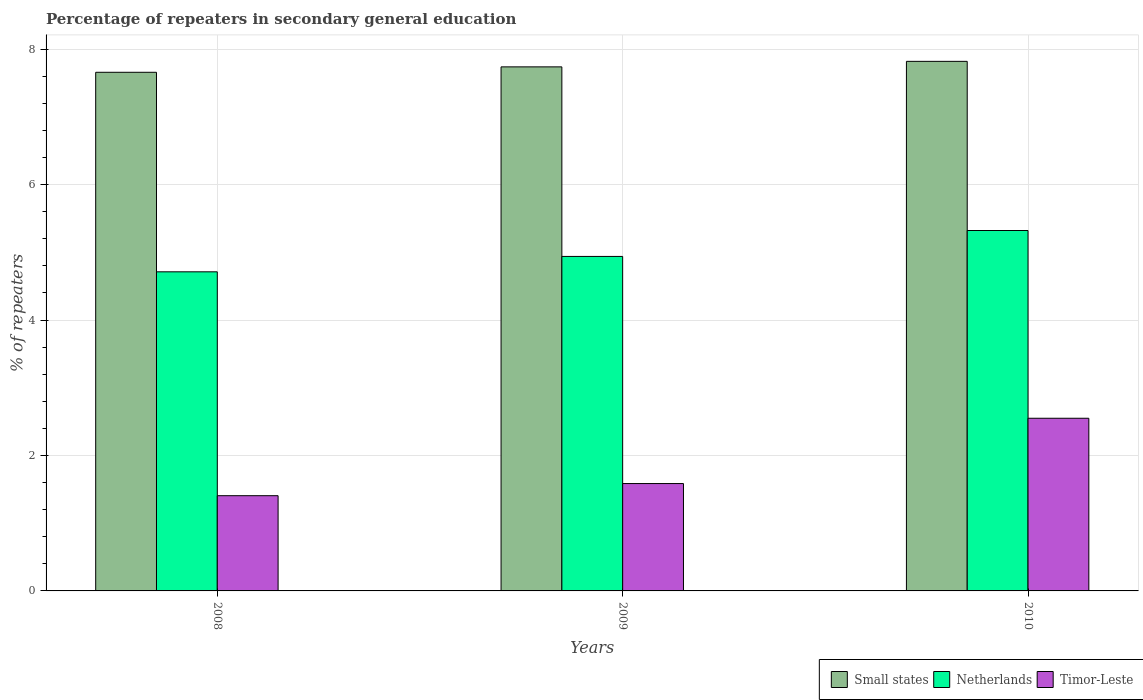How many bars are there on the 1st tick from the left?
Ensure brevity in your answer.  3. How many bars are there on the 1st tick from the right?
Your response must be concise. 3. In how many cases, is the number of bars for a given year not equal to the number of legend labels?
Your response must be concise. 0. What is the percentage of repeaters in secondary general education in Small states in 2008?
Offer a very short reply. 7.66. Across all years, what is the maximum percentage of repeaters in secondary general education in Timor-Leste?
Offer a very short reply. 2.55. Across all years, what is the minimum percentage of repeaters in secondary general education in Timor-Leste?
Offer a terse response. 1.41. In which year was the percentage of repeaters in secondary general education in Small states maximum?
Your answer should be very brief. 2010. In which year was the percentage of repeaters in secondary general education in Small states minimum?
Ensure brevity in your answer.  2008. What is the total percentage of repeaters in secondary general education in Netherlands in the graph?
Offer a terse response. 14.97. What is the difference between the percentage of repeaters in secondary general education in Small states in 2008 and that in 2010?
Your answer should be compact. -0.16. What is the difference between the percentage of repeaters in secondary general education in Small states in 2008 and the percentage of repeaters in secondary general education in Timor-Leste in 2009?
Keep it short and to the point. 6.07. What is the average percentage of repeaters in secondary general education in Small states per year?
Your answer should be very brief. 7.74. In the year 2010, what is the difference between the percentage of repeaters in secondary general education in Small states and percentage of repeaters in secondary general education in Timor-Leste?
Make the answer very short. 5.27. What is the ratio of the percentage of repeaters in secondary general education in Netherlands in 2009 to that in 2010?
Provide a short and direct response. 0.93. What is the difference between the highest and the second highest percentage of repeaters in secondary general education in Timor-Leste?
Provide a succinct answer. 0.96. What is the difference between the highest and the lowest percentage of repeaters in secondary general education in Netherlands?
Offer a very short reply. 0.61. How many bars are there?
Your response must be concise. 9. How many years are there in the graph?
Offer a terse response. 3. Are the values on the major ticks of Y-axis written in scientific E-notation?
Offer a terse response. No. Does the graph contain grids?
Give a very brief answer. Yes. How many legend labels are there?
Make the answer very short. 3. What is the title of the graph?
Your answer should be very brief. Percentage of repeaters in secondary general education. What is the label or title of the X-axis?
Keep it short and to the point. Years. What is the label or title of the Y-axis?
Offer a very short reply. % of repeaters. What is the % of repeaters of Small states in 2008?
Provide a succinct answer. 7.66. What is the % of repeaters of Netherlands in 2008?
Ensure brevity in your answer.  4.71. What is the % of repeaters of Timor-Leste in 2008?
Keep it short and to the point. 1.41. What is the % of repeaters in Small states in 2009?
Provide a short and direct response. 7.74. What is the % of repeaters in Netherlands in 2009?
Provide a succinct answer. 4.94. What is the % of repeaters of Timor-Leste in 2009?
Give a very brief answer. 1.59. What is the % of repeaters of Small states in 2010?
Ensure brevity in your answer.  7.82. What is the % of repeaters of Netherlands in 2010?
Provide a succinct answer. 5.32. What is the % of repeaters in Timor-Leste in 2010?
Keep it short and to the point. 2.55. Across all years, what is the maximum % of repeaters in Small states?
Provide a short and direct response. 7.82. Across all years, what is the maximum % of repeaters in Netherlands?
Provide a short and direct response. 5.32. Across all years, what is the maximum % of repeaters of Timor-Leste?
Your answer should be compact. 2.55. Across all years, what is the minimum % of repeaters in Small states?
Your answer should be compact. 7.66. Across all years, what is the minimum % of repeaters of Netherlands?
Provide a succinct answer. 4.71. Across all years, what is the minimum % of repeaters of Timor-Leste?
Give a very brief answer. 1.41. What is the total % of repeaters of Small states in the graph?
Offer a very short reply. 23.22. What is the total % of repeaters of Netherlands in the graph?
Your answer should be very brief. 14.97. What is the total % of repeaters in Timor-Leste in the graph?
Provide a succinct answer. 5.54. What is the difference between the % of repeaters of Small states in 2008 and that in 2009?
Give a very brief answer. -0.08. What is the difference between the % of repeaters of Netherlands in 2008 and that in 2009?
Offer a terse response. -0.23. What is the difference between the % of repeaters of Timor-Leste in 2008 and that in 2009?
Give a very brief answer. -0.18. What is the difference between the % of repeaters in Small states in 2008 and that in 2010?
Keep it short and to the point. -0.16. What is the difference between the % of repeaters in Netherlands in 2008 and that in 2010?
Make the answer very short. -0.61. What is the difference between the % of repeaters of Timor-Leste in 2008 and that in 2010?
Give a very brief answer. -1.14. What is the difference between the % of repeaters in Small states in 2009 and that in 2010?
Ensure brevity in your answer.  -0.08. What is the difference between the % of repeaters of Netherlands in 2009 and that in 2010?
Ensure brevity in your answer.  -0.38. What is the difference between the % of repeaters in Timor-Leste in 2009 and that in 2010?
Ensure brevity in your answer.  -0.96. What is the difference between the % of repeaters of Small states in 2008 and the % of repeaters of Netherlands in 2009?
Offer a terse response. 2.72. What is the difference between the % of repeaters in Small states in 2008 and the % of repeaters in Timor-Leste in 2009?
Give a very brief answer. 6.07. What is the difference between the % of repeaters of Netherlands in 2008 and the % of repeaters of Timor-Leste in 2009?
Give a very brief answer. 3.13. What is the difference between the % of repeaters in Small states in 2008 and the % of repeaters in Netherlands in 2010?
Your answer should be very brief. 2.34. What is the difference between the % of repeaters in Small states in 2008 and the % of repeaters in Timor-Leste in 2010?
Your answer should be very brief. 5.11. What is the difference between the % of repeaters of Netherlands in 2008 and the % of repeaters of Timor-Leste in 2010?
Make the answer very short. 2.16. What is the difference between the % of repeaters of Small states in 2009 and the % of repeaters of Netherlands in 2010?
Your answer should be very brief. 2.42. What is the difference between the % of repeaters of Small states in 2009 and the % of repeaters of Timor-Leste in 2010?
Provide a short and direct response. 5.19. What is the difference between the % of repeaters of Netherlands in 2009 and the % of repeaters of Timor-Leste in 2010?
Offer a terse response. 2.39. What is the average % of repeaters in Small states per year?
Offer a terse response. 7.74. What is the average % of repeaters in Netherlands per year?
Provide a short and direct response. 4.99. What is the average % of repeaters in Timor-Leste per year?
Offer a very short reply. 1.85. In the year 2008, what is the difference between the % of repeaters in Small states and % of repeaters in Netherlands?
Provide a short and direct response. 2.95. In the year 2008, what is the difference between the % of repeaters of Small states and % of repeaters of Timor-Leste?
Your answer should be very brief. 6.25. In the year 2008, what is the difference between the % of repeaters in Netherlands and % of repeaters in Timor-Leste?
Your answer should be compact. 3.31. In the year 2009, what is the difference between the % of repeaters of Small states and % of repeaters of Netherlands?
Your response must be concise. 2.8. In the year 2009, what is the difference between the % of repeaters of Small states and % of repeaters of Timor-Leste?
Offer a terse response. 6.15. In the year 2009, what is the difference between the % of repeaters of Netherlands and % of repeaters of Timor-Leste?
Your response must be concise. 3.35. In the year 2010, what is the difference between the % of repeaters in Small states and % of repeaters in Netherlands?
Provide a short and direct response. 2.5. In the year 2010, what is the difference between the % of repeaters in Small states and % of repeaters in Timor-Leste?
Ensure brevity in your answer.  5.27. In the year 2010, what is the difference between the % of repeaters of Netherlands and % of repeaters of Timor-Leste?
Offer a very short reply. 2.77. What is the ratio of the % of repeaters in Small states in 2008 to that in 2009?
Give a very brief answer. 0.99. What is the ratio of the % of repeaters of Netherlands in 2008 to that in 2009?
Make the answer very short. 0.95. What is the ratio of the % of repeaters of Timor-Leste in 2008 to that in 2009?
Provide a succinct answer. 0.89. What is the ratio of the % of repeaters in Small states in 2008 to that in 2010?
Your answer should be compact. 0.98. What is the ratio of the % of repeaters of Netherlands in 2008 to that in 2010?
Provide a succinct answer. 0.89. What is the ratio of the % of repeaters of Timor-Leste in 2008 to that in 2010?
Offer a terse response. 0.55. What is the ratio of the % of repeaters of Small states in 2009 to that in 2010?
Ensure brevity in your answer.  0.99. What is the ratio of the % of repeaters of Netherlands in 2009 to that in 2010?
Your answer should be very brief. 0.93. What is the ratio of the % of repeaters of Timor-Leste in 2009 to that in 2010?
Offer a very short reply. 0.62. What is the difference between the highest and the second highest % of repeaters in Small states?
Your response must be concise. 0.08. What is the difference between the highest and the second highest % of repeaters in Netherlands?
Give a very brief answer. 0.38. What is the difference between the highest and the second highest % of repeaters of Timor-Leste?
Offer a terse response. 0.96. What is the difference between the highest and the lowest % of repeaters in Small states?
Ensure brevity in your answer.  0.16. What is the difference between the highest and the lowest % of repeaters in Netherlands?
Ensure brevity in your answer.  0.61. What is the difference between the highest and the lowest % of repeaters in Timor-Leste?
Provide a short and direct response. 1.14. 